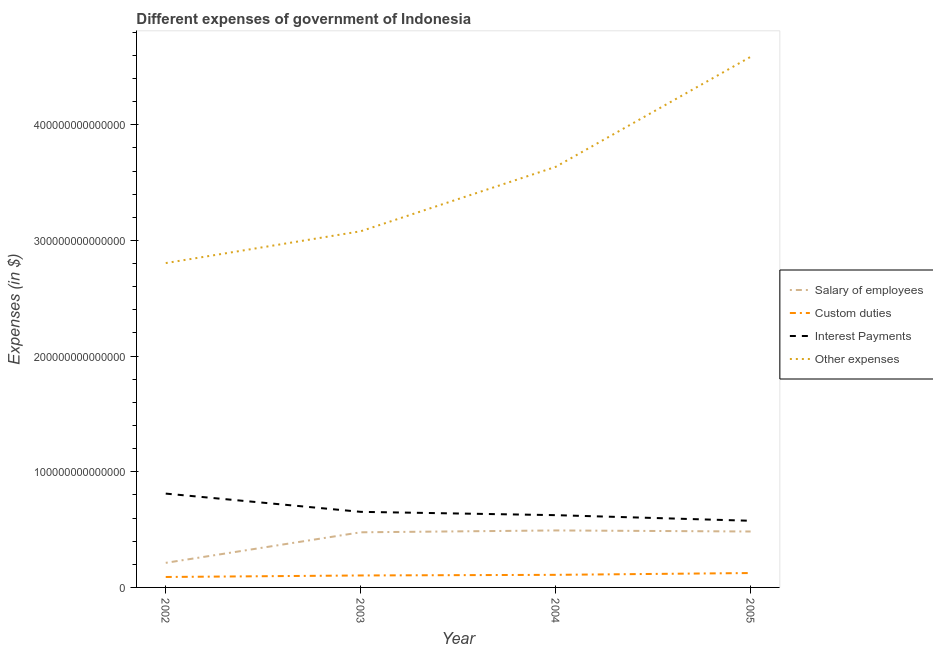Does the line corresponding to amount spent on salary of employees intersect with the line corresponding to amount spent on interest payments?
Ensure brevity in your answer.  No. What is the amount spent on salary of employees in 2002?
Your answer should be very brief. 2.13e+13. Across all years, what is the maximum amount spent on interest payments?
Your answer should be compact. 8.11e+13. Across all years, what is the minimum amount spent on interest payments?
Offer a very short reply. 5.76e+13. In which year was the amount spent on custom duties maximum?
Your response must be concise. 2005. What is the total amount spent on interest payments in the graph?
Provide a short and direct response. 2.67e+14. What is the difference between the amount spent on custom duties in 2003 and that in 2005?
Offer a very short reply. -2.10e+12. What is the difference between the amount spent on salary of employees in 2005 and the amount spent on custom duties in 2003?
Offer a very short reply. 3.80e+13. What is the average amount spent on other expenses per year?
Your response must be concise. 3.53e+14. In the year 2002, what is the difference between the amount spent on custom duties and amount spent on interest payments?
Offer a very short reply. -7.21e+13. In how many years, is the amount spent on interest payments greater than 380000000000000 $?
Your response must be concise. 0. What is the ratio of the amount spent on interest payments in 2002 to that in 2005?
Provide a succinct answer. 1.41. Is the amount spent on custom duties in 2003 less than that in 2004?
Offer a very short reply. Yes. What is the difference between the highest and the second highest amount spent on other expenses?
Provide a short and direct response. 9.51e+13. What is the difference between the highest and the lowest amount spent on other expenses?
Keep it short and to the point. 1.78e+14. In how many years, is the amount spent on interest payments greater than the average amount spent on interest payments taken over all years?
Your answer should be compact. 1. Is it the case that in every year, the sum of the amount spent on salary of employees and amount spent on other expenses is greater than the sum of amount spent on custom duties and amount spent on interest payments?
Offer a very short reply. No. What is the difference between two consecutive major ticks on the Y-axis?
Your response must be concise. 1.00e+14. Are the values on the major ticks of Y-axis written in scientific E-notation?
Give a very brief answer. No. Does the graph contain any zero values?
Offer a very short reply. No. What is the title of the graph?
Ensure brevity in your answer.  Different expenses of government of Indonesia. What is the label or title of the X-axis?
Offer a terse response. Year. What is the label or title of the Y-axis?
Your answer should be compact. Expenses (in $). What is the Expenses (in $) of Salary of employees in 2002?
Ensure brevity in your answer.  2.13e+13. What is the Expenses (in $) of Custom duties in 2002?
Your answer should be compact. 9.03e+12. What is the Expenses (in $) in Interest Payments in 2002?
Your answer should be compact. 8.11e+13. What is the Expenses (in $) of Other expenses in 2002?
Offer a very short reply. 2.80e+14. What is the Expenses (in $) of Salary of employees in 2003?
Your answer should be very brief. 4.77e+13. What is the Expenses (in $) of Custom duties in 2003?
Provide a succinct answer. 1.03e+13. What is the Expenses (in $) in Interest Payments in 2003?
Keep it short and to the point. 6.54e+13. What is the Expenses (in $) in Other expenses in 2003?
Your answer should be very brief. 3.08e+14. What is the Expenses (in $) in Salary of employees in 2004?
Make the answer very short. 4.93e+13. What is the Expenses (in $) in Custom duties in 2004?
Give a very brief answer. 1.09e+13. What is the Expenses (in $) of Interest Payments in 2004?
Provide a short and direct response. 6.25e+13. What is the Expenses (in $) of Other expenses in 2004?
Offer a terse response. 3.64e+14. What is the Expenses (in $) in Salary of employees in 2005?
Offer a very short reply. 4.84e+13. What is the Expenses (in $) of Custom duties in 2005?
Offer a very short reply. 1.24e+13. What is the Expenses (in $) of Interest Payments in 2005?
Offer a very short reply. 5.76e+13. What is the Expenses (in $) of Other expenses in 2005?
Offer a very short reply. 4.59e+14. Across all years, what is the maximum Expenses (in $) of Salary of employees?
Make the answer very short. 4.93e+13. Across all years, what is the maximum Expenses (in $) in Custom duties?
Your answer should be compact. 1.24e+13. Across all years, what is the maximum Expenses (in $) of Interest Payments?
Offer a very short reply. 8.11e+13. Across all years, what is the maximum Expenses (in $) of Other expenses?
Offer a very short reply. 4.59e+14. Across all years, what is the minimum Expenses (in $) in Salary of employees?
Offer a very short reply. 2.13e+13. Across all years, what is the minimum Expenses (in $) in Custom duties?
Keep it short and to the point. 9.03e+12. Across all years, what is the minimum Expenses (in $) of Interest Payments?
Keep it short and to the point. 5.76e+13. Across all years, what is the minimum Expenses (in $) in Other expenses?
Offer a very short reply. 2.80e+14. What is the total Expenses (in $) in Salary of employees in the graph?
Offer a very short reply. 1.67e+14. What is the total Expenses (in $) in Custom duties in the graph?
Offer a terse response. 4.27e+13. What is the total Expenses (in $) of Interest Payments in the graph?
Provide a short and direct response. 2.67e+14. What is the total Expenses (in $) of Other expenses in the graph?
Give a very brief answer. 1.41e+15. What is the difference between the Expenses (in $) in Salary of employees in 2002 and that in 2003?
Your answer should be very brief. -2.64e+13. What is the difference between the Expenses (in $) in Custom duties in 2002 and that in 2003?
Provide a short and direct response. -1.32e+12. What is the difference between the Expenses (in $) in Interest Payments in 2002 and that in 2003?
Make the answer very short. 1.58e+13. What is the difference between the Expenses (in $) of Other expenses in 2002 and that in 2003?
Keep it short and to the point. -2.75e+13. What is the difference between the Expenses (in $) in Salary of employees in 2002 and that in 2004?
Offer a very short reply. -2.80e+13. What is the difference between the Expenses (in $) in Custom duties in 2002 and that in 2004?
Your response must be concise. -1.86e+12. What is the difference between the Expenses (in $) in Interest Payments in 2002 and that in 2004?
Offer a very short reply. 1.86e+13. What is the difference between the Expenses (in $) in Other expenses in 2002 and that in 2004?
Give a very brief answer. -8.32e+13. What is the difference between the Expenses (in $) of Salary of employees in 2002 and that in 2005?
Keep it short and to the point. -2.71e+13. What is the difference between the Expenses (in $) in Custom duties in 2002 and that in 2005?
Provide a succinct answer. -3.42e+12. What is the difference between the Expenses (in $) of Interest Payments in 2002 and that in 2005?
Your answer should be very brief. 2.35e+13. What is the difference between the Expenses (in $) of Other expenses in 2002 and that in 2005?
Your answer should be very brief. -1.78e+14. What is the difference between the Expenses (in $) of Salary of employees in 2003 and that in 2004?
Make the answer very short. -1.61e+12. What is the difference between the Expenses (in $) of Custom duties in 2003 and that in 2004?
Offer a terse response. -5.40e+11. What is the difference between the Expenses (in $) of Interest Payments in 2003 and that in 2004?
Provide a succinct answer. 2.86e+12. What is the difference between the Expenses (in $) of Other expenses in 2003 and that in 2004?
Your answer should be compact. -5.57e+13. What is the difference between the Expenses (in $) of Salary of employees in 2003 and that in 2005?
Provide a short and direct response. -6.89e+11. What is the difference between the Expenses (in $) in Custom duties in 2003 and that in 2005?
Your response must be concise. -2.10e+12. What is the difference between the Expenses (in $) of Interest Payments in 2003 and that in 2005?
Offer a terse response. 7.72e+12. What is the difference between the Expenses (in $) of Other expenses in 2003 and that in 2005?
Make the answer very short. -1.51e+14. What is the difference between the Expenses (in $) of Salary of employees in 2004 and that in 2005?
Offer a terse response. 9.19e+11. What is the difference between the Expenses (in $) in Custom duties in 2004 and that in 2005?
Offer a terse response. -1.56e+12. What is the difference between the Expenses (in $) of Interest Payments in 2004 and that in 2005?
Offer a very short reply. 4.85e+12. What is the difference between the Expenses (in $) in Other expenses in 2004 and that in 2005?
Your answer should be compact. -9.51e+13. What is the difference between the Expenses (in $) in Salary of employees in 2002 and the Expenses (in $) in Custom duties in 2003?
Give a very brief answer. 1.09e+13. What is the difference between the Expenses (in $) in Salary of employees in 2002 and the Expenses (in $) in Interest Payments in 2003?
Provide a succinct answer. -4.41e+13. What is the difference between the Expenses (in $) in Salary of employees in 2002 and the Expenses (in $) in Other expenses in 2003?
Give a very brief answer. -2.87e+14. What is the difference between the Expenses (in $) in Custom duties in 2002 and the Expenses (in $) in Interest Payments in 2003?
Your answer should be very brief. -5.63e+13. What is the difference between the Expenses (in $) in Custom duties in 2002 and the Expenses (in $) in Other expenses in 2003?
Provide a short and direct response. -2.99e+14. What is the difference between the Expenses (in $) in Interest Payments in 2002 and the Expenses (in $) in Other expenses in 2003?
Provide a succinct answer. -2.27e+14. What is the difference between the Expenses (in $) in Salary of employees in 2002 and the Expenses (in $) in Custom duties in 2004?
Offer a very short reply. 1.04e+13. What is the difference between the Expenses (in $) of Salary of employees in 2002 and the Expenses (in $) of Interest Payments in 2004?
Provide a succinct answer. -4.12e+13. What is the difference between the Expenses (in $) in Salary of employees in 2002 and the Expenses (in $) in Other expenses in 2004?
Offer a very short reply. -3.42e+14. What is the difference between the Expenses (in $) in Custom duties in 2002 and the Expenses (in $) in Interest Payments in 2004?
Provide a short and direct response. -5.35e+13. What is the difference between the Expenses (in $) in Custom duties in 2002 and the Expenses (in $) in Other expenses in 2004?
Offer a terse response. -3.55e+14. What is the difference between the Expenses (in $) of Interest Payments in 2002 and the Expenses (in $) of Other expenses in 2004?
Offer a very short reply. -2.82e+14. What is the difference between the Expenses (in $) of Salary of employees in 2002 and the Expenses (in $) of Custom duties in 2005?
Your answer should be compact. 8.82e+12. What is the difference between the Expenses (in $) of Salary of employees in 2002 and the Expenses (in $) of Interest Payments in 2005?
Offer a terse response. -3.64e+13. What is the difference between the Expenses (in $) in Salary of employees in 2002 and the Expenses (in $) in Other expenses in 2005?
Give a very brief answer. -4.37e+14. What is the difference between the Expenses (in $) of Custom duties in 2002 and the Expenses (in $) of Interest Payments in 2005?
Make the answer very short. -4.86e+13. What is the difference between the Expenses (in $) in Custom duties in 2002 and the Expenses (in $) in Other expenses in 2005?
Offer a very short reply. -4.50e+14. What is the difference between the Expenses (in $) of Interest Payments in 2002 and the Expenses (in $) of Other expenses in 2005?
Your answer should be very brief. -3.78e+14. What is the difference between the Expenses (in $) in Salary of employees in 2003 and the Expenses (in $) in Custom duties in 2004?
Offer a very short reply. 3.68e+13. What is the difference between the Expenses (in $) of Salary of employees in 2003 and the Expenses (in $) of Interest Payments in 2004?
Keep it short and to the point. -1.48e+13. What is the difference between the Expenses (in $) of Salary of employees in 2003 and the Expenses (in $) of Other expenses in 2004?
Make the answer very short. -3.16e+14. What is the difference between the Expenses (in $) in Custom duties in 2003 and the Expenses (in $) in Interest Payments in 2004?
Your answer should be compact. -5.21e+13. What is the difference between the Expenses (in $) of Custom duties in 2003 and the Expenses (in $) of Other expenses in 2004?
Offer a very short reply. -3.53e+14. What is the difference between the Expenses (in $) in Interest Payments in 2003 and the Expenses (in $) in Other expenses in 2004?
Offer a terse response. -2.98e+14. What is the difference between the Expenses (in $) in Salary of employees in 2003 and the Expenses (in $) in Custom duties in 2005?
Your answer should be very brief. 3.52e+13. What is the difference between the Expenses (in $) of Salary of employees in 2003 and the Expenses (in $) of Interest Payments in 2005?
Your answer should be very brief. -9.97e+12. What is the difference between the Expenses (in $) of Salary of employees in 2003 and the Expenses (in $) of Other expenses in 2005?
Provide a short and direct response. -4.11e+14. What is the difference between the Expenses (in $) in Custom duties in 2003 and the Expenses (in $) in Interest Payments in 2005?
Give a very brief answer. -4.73e+13. What is the difference between the Expenses (in $) in Custom duties in 2003 and the Expenses (in $) in Other expenses in 2005?
Make the answer very short. -4.48e+14. What is the difference between the Expenses (in $) in Interest Payments in 2003 and the Expenses (in $) in Other expenses in 2005?
Provide a short and direct response. -3.93e+14. What is the difference between the Expenses (in $) of Salary of employees in 2004 and the Expenses (in $) of Custom duties in 2005?
Your answer should be compact. 3.68e+13. What is the difference between the Expenses (in $) in Salary of employees in 2004 and the Expenses (in $) in Interest Payments in 2005?
Your response must be concise. -8.36e+12. What is the difference between the Expenses (in $) of Salary of employees in 2004 and the Expenses (in $) of Other expenses in 2005?
Offer a very short reply. -4.09e+14. What is the difference between the Expenses (in $) in Custom duties in 2004 and the Expenses (in $) in Interest Payments in 2005?
Provide a succinct answer. -4.67e+13. What is the difference between the Expenses (in $) of Custom duties in 2004 and the Expenses (in $) of Other expenses in 2005?
Provide a succinct answer. -4.48e+14. What is the difference between the Expenses (in $) of Interest Payments in 2004 and the Expenses (in $) of Other expenses in 2005?
Keep it short and to the point. -3.96e+14. What is the average Expenses (in $) in Salary of employees per year?
Give a very brief answer. 4.16e+13. What is the average Expenses (in $) of Custom duties per year?
Ensure brevity in your answer.  1.07e+13. What is the average Expenses (in $) in Interest Payments per year?
Give a very brief answer. 6.66e+13. What is the average Expenses (in $) of Other expenses per year?
Your response must be concise. 3.53e+14. In the year 2002, what is the difference between the Expenses (in $) of Salary of employees and Expenses (in $) of Custom duties?
Provide a short and direct response. 1.22e+13. In the year 2002, what is the difference between the Expenses (in $) in Salary of employees and Expenses (in $) in Interest Payments?
Your response must be concise. -5.99e+13. In the year 2002, what is the difference between the Expenses (in $) in Salary of employees and Expenses (in $) in Other expenses?
Your answer should be very brief. -2.59e+14. In the year 2002, what is the difference between the Expenses (in $) in Custom duties and Expenses (in $) in Interest Payments?
Your answer should be compact. -7.21e+13. In the year 2002, what is the difference between the Expenses (in $) in Custom duties and Expenses (in $) in Other expenses?
Ensure brevity in your answer.  -2.71e+14. In the year 2002, what is the difference between the Expenses (in $) in Interest Payments and Expenses (in $) in Other expenses?
Offer a very short reply. -1.99e+14. In the year 2003, what is the difference between the Expenses (in $) in Salary of employees and Expenses (in $) in Custom duties?
Provide a succinct answer. 3.73e+13. In the year 2003, what is the difference between the Expenses (in $) of Salary of employees and Expenses (in $) of Interest Payments?
Give a very brief answer. -1.77e+13. In the year 2003, what is the difference between the Expenses (in $) in Salary of employees and Expenses (in $) in Other expenses?
Your response must be concise. -2.60e+14. In the year 2003, what is the difference between the Expenses (in $) in Custom duties and Expenses (in $) in Interest Payments?
Provide a short and direct response. -5.50e+13. In the year 2003, what is the difference between the Expenses (in $) of Custom duties and Expenses (in $) of Other expenses?
Give a very brief answer. -2.98e+14. In the year 2003, what is the difference between the Expenses (in $) of Interest Payments and Expenses (in $) of Other expenses?
Ensure brevity in your answer.  -2.43e+14. In the year 2004, what is the difference between the Expenses (in $) in Salary of employees and Expenses (in $) in Custom duties?
Your answer should be compact. 3.84e+13. In the year 2004, what is the difference between the Expenses (in $) in Salary of employees and Expenses (in $) in Interest Payments?
Make the answer very short. -1.32e+13. In the year 2004, what is the difference between the Expenses (in $) of Salary of employees and Expenses (in $) of Other expenses?
Provide a short and direct response. -3.14e+14. In the year 2004, what is the difference between the Expenses (in $) of Custom duties and Expenses (in $) of Interest Payments?
Keep it short and to the point. -5.16e+13. In the year 2004, what is the difference between the Expenses (in $) of Custom duties and Expenses (in $) of Other expenses?
Ensure brevity in your answer.  -3.53e+14. In the year 2004, what is the difference between the Expenses (in $) in Interest Payments and Expenses (in $) in Other expenses?
Your answer should be compact. -3.01e+14. In the year 2005, what is the difference between the Expenses (in $) of Salary of employees and Expenses (in $) of Custom duties?
Make the answer very short. 3.59e+13. In the year 2005, what is the difference between the Expenses (in $) of Salary of employees and Expenses (in $) of Interest Payments?
Your answer should be compact. -9.28e+12. In the year 2005, what is the difference between the Expenses (in $) in Salary of employees and Expenses (in $) in Other expenses?
Your answer should be compact. -4.10e+14. In the year 2005, what is the difference between the Expenses (in $) in Custom duties and Expenses (in $) in Interest Payments?
Provide a succinct answer. -4.52e+13. In the year 2005, what is the difference between the Expenses (in $) of Custom duties and Expenses (in $) of Other expenses?
Ensure brevity in your answer.  -4.46e+14. In the year 2005, what is the difference between the Expenses (in $) in Interest Payments and Expenses (in $) in Other expenses?
Offer a very short reply. -4.01e+14. What is the ratio of the Expenses (in $) in Salary of employees in 2002 to that in 2003?
Your answer should be compact. 0.45. What is the ratio of the Expenses (in $) of Custom duties in 2002 to that in 2003?
Provide a succinct answer. 0.87. What is the ratio of the Expenses (in $) in Interest Payments in 2002 to that in 2003?
Your answer should be very brief. 1.24. What is the ratio of the Expenses (in $) of Other expenses in 2002 to that in 2003?
Your answer should be very brief. 0.91. What is the ratio of the Expenses (in $) of Salary of employees in 2002 to that in 2004?
Provide a succinct answer. 0.43. What is the ratio of the Expenses (in $) in Custom duties in 2002 to that in 2004?
Offer a very short reply. 0.83. What is the ratio of the Expenses (in $) in Interest Payments in 2002 to that in 2004?
Offer a very short reply. 1.3. What is the ratio of the Expenses (in $) of Other expenses in 2002 to that in 2004?
Your answer should be very brief. 0.77. What is the ratio of the Expenses (in $) of Salary of employees in 2002 to that in 2005?
Offer a very short reply. 0.44. What is the ratio of the Expenses (in $) of Custom duties in 2002 to that in 2005?
Your response must be concise. 0.73. What is the ratio of the Expenses (in $) in Interest Payments in 2002 to that in 2005?
Provide a succinct answer. 1.41. What is the ratio of the Expenses (in $) of Other expenses in 2002 to that in 2005?
Your answer should be very brief. 0.61. What is the ratio of the Expenses (in $) of Salary of employees in 2003 to that in 2004?
Offer a terse response. 0.97. What is the ratio of the Expenses (in $) of Custom duties in 2003 to that in 2004?
Keep it short and to the point. 0.95. What is the ratio of the Expenses (in $) of Interest Payments in 2003 to that in 2004?
Your answer should be compact. 1.05. What is the ratio of the Expenses (in $) of Other expenses in 2003 to that in 2004?
Ensure brevity in your answer.  0.85. What is the ratio of the Expenses (in $) of Salary of employees in 2003 to that in 2005?
Provide a short and direct response. 0.99. What is the ratio of the Expenses (in $) of Custom duties in 2003 to that in 2005?
Ensure brevity in your answer.  0.83. What is the ratio of the Expenses (in $) in Interest Payments in 2003 to that in 2005?
Offer a very short reply. 1.13. What is the ratio of the Expenses (in $) in Other expenses in 2003 to that in 2005?
Provide a succinct answer. 0.67. What is the ratio of the Expenses (in $) of Custom duties in 2004 to that in 2005?
Make the answer very short. 0.87. What is the ratio of the Expenses (in $) in Interest Payments in 2004 to that in 2005?
Make the answer very short. 1.08. What is the ratio of the Expenses (in $) of Other expenses in 2004 to that in 2005?
Keep it short and to the point. 0.79. What is the difference between the highest and the second highest Expenses (in $) in Salary of employees?
Provide a short and direct response. 9.19e+11. What is the difference between the highest and the second highest Expenses (in $) in Custom duties?
Provide a succinct answer. 1.56e+12. What is the difference between the highest and the second highest Expenses (in $) in Interest Payments?
Your response must be concise. 1.58e+13. What is the difference between the highest and the second highest Expenses (in $) in Other expenses?
Make the answer very short. 9.51e+13. What is the difference between the highest and the lowest Expenses (in $) of Salary of employees?
Provide a short and direct response. 2.80e+13. What is the difference between the highest and the lowest Expenses (in $) of Custom duties?
Give a very brief answer. 3.42e+12. What is the difference between the highest and the lowest Expenses (in $) of Interest Payments?
Your answer should be very brief. 2.35e+13. What is the difference between the highest and the lowest Expenses (in $) of Other expenses?
Offer a terse response. 1.78e+14. 